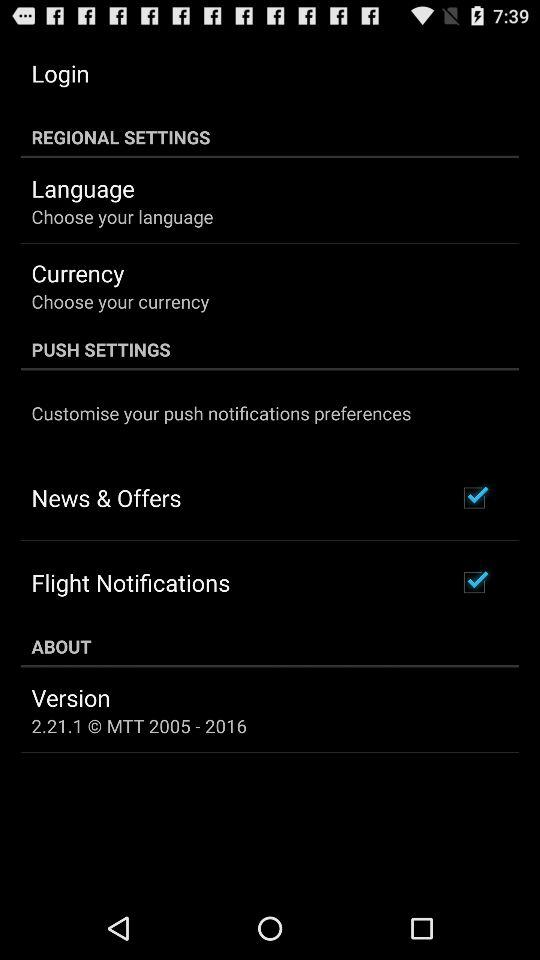What is the status of "Flight Notifications"? The status is "on". 